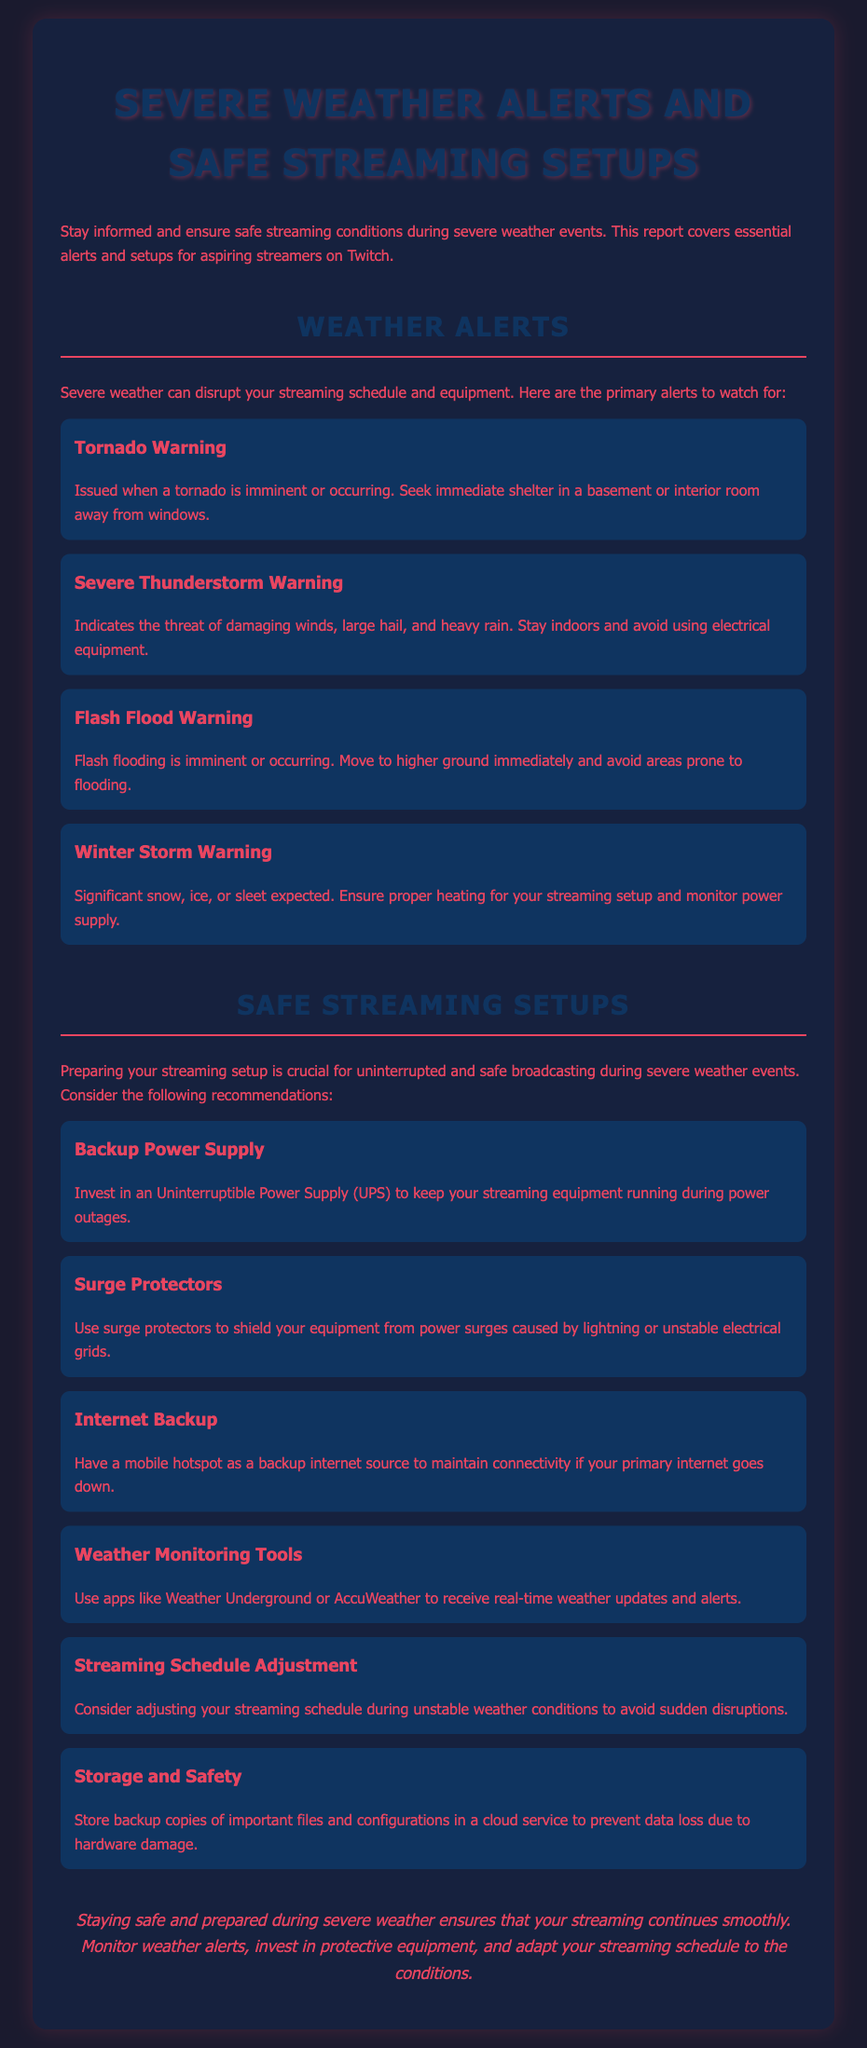What is the title of the document? The title is stated in the <title> tag of the HTML, which is "Severe Weather Alerts for Streamers."
Answer: Severe Weather Alerts for Streamers What is a Tornado Warning? A Tornado Warning is defined as being issued when a tornado is imminent or occurring.
Answer: Issued when a tornado is imminent or occurring What should you do during a Flash Flood Warning? The document advises moving to higher ground immediately during a Flash Flood Warning.
Answer: Move to higher ground immediately How should you protect your equipment from power surges? The document recommends using surge protectors to shield your equipment from power surges.
Answer: Use surge protectors What is a suggested tool for weather monitoring? The document mentions using apps like Weather Underground or AccuWeather for weather monitoring.
Answer: Weather Underground or AccuWeather What is the purpose of an Uninterruptible Power Supply? The document states that an Uninterruptible Power Supply (UPS) keeps your streaming equipment running during power outages.
Answer: To keep streaming equipment running during power outages What adjustment is recommended for streaming during severe weather? The document suggests considering adjusting your streaming schedule during unstable weather conditions.
Answer: Adjusting your streaming schedule What color is the background of the document? The background color is specified in the CSS style as #1a1a2e.
Answer: #1a1a2e What type of document is this? This document is a weather report specifically aimed at streamers regarding severe weather alerts and safe setups.
Answer: Weather report 